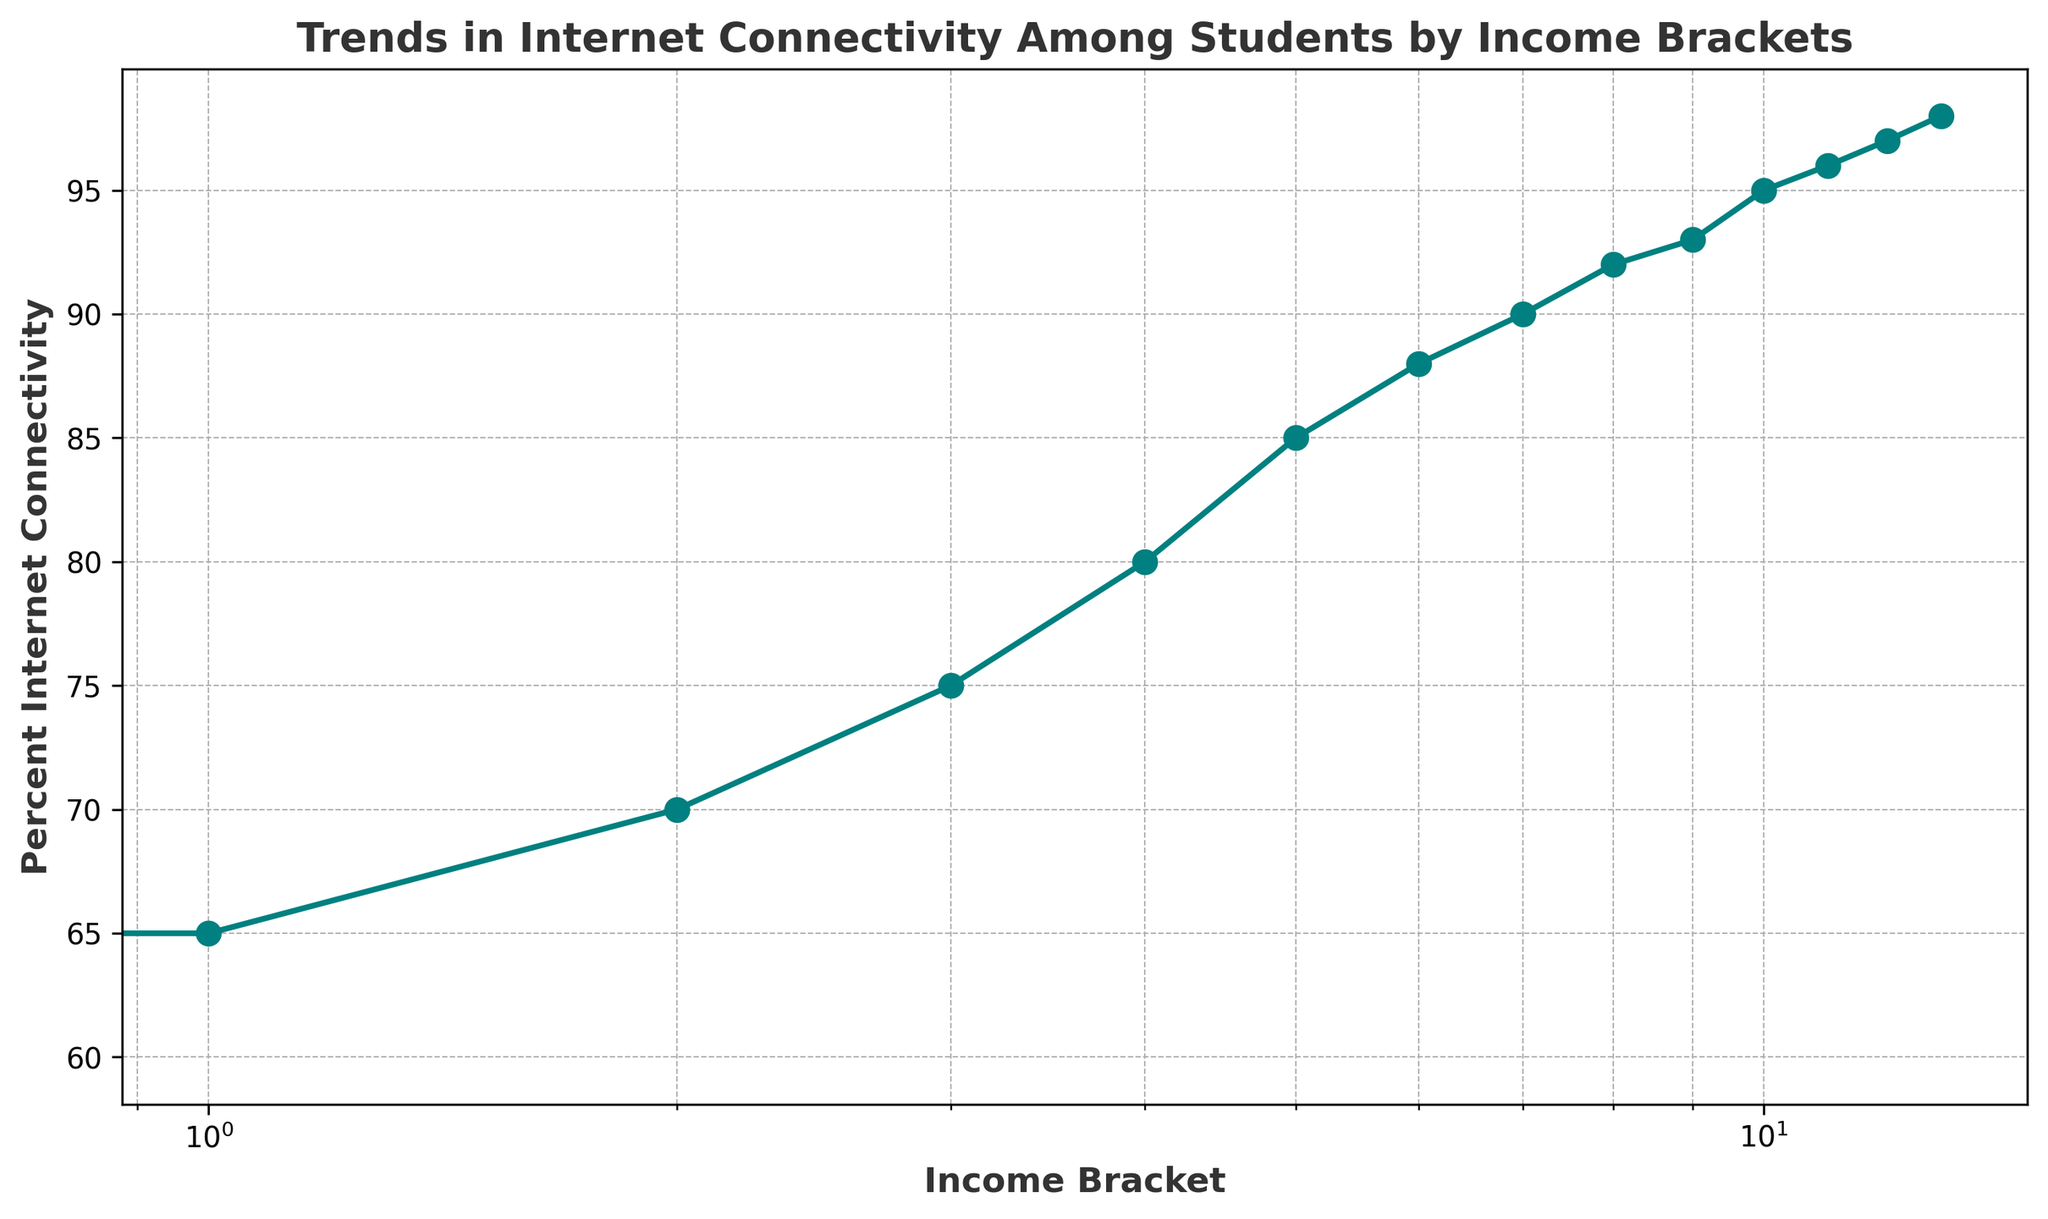What is the percentage of internet connectivity for students with income less than $10k? Locate the data point corresponding to "Less_than_10k" on the income bracket axis. The y-axis value at this point indicates the percentage, which is 60%.
Answer: 60% How much higher is the internet connectivity for students with income between $20k and $30k compared to those with income less than $10k? Identify the y-axis values for "20k_to_30k" and "Less_than_10k", which are 70% and 60%, respectively. Subtract the lower percentage from the higher one: 70% - 60% = 10%.
Answer: 10% Which income bracket has the highest percentage of internet connectivity? Look at the plot and find the data point with the highest y-axis value. The highest percentage is at "More_than_200k" with 98%.
Answer: More_than_200k What is the average percentage of internet connectivity for income brackets ranging from $50k to $100k? Identify the y-axis values for the income brackets "50k_to_60k", "60k_to_70k", "70k_to_80k", "80k_to_90k", and "90k_to_100k", which are 85%, 88%, 90%, 92%, and 93% respectively. Calculate the average: (85 + 88 + 90 + 92 + 93) / 5 = 89.6%.
Answer: 89.6% Is there an income bracket where the percentage of internet connectivity is exactly 80%? Locate the data points on the plot and check the y-axis values. The connectivity percentage is exactly 80% at the "40k_to_50k" income bracket.
Answer: 40k_to_50k Between which two consecutive income brackets does the largest increase in internet connectivity percentage occur? Check the differences between consecutive y-axis values: 
  - 10k_to_20k - Less_than_10k: 65% - 60% = 5%
  - 20k_to_30k - 10k_to_20k: 70% - 65% = 5%
  - 30k_to_40k - 20k_to_30k: 75% - 70% = 5%
  - 40k_to_50k - 30k_to_40k: 80% - 75% = 5%
  - 50k_to_60k - 40k_to_50k: 85% - 80% = 5%
  - 60k_to_70k - 50k_to_60k: 88% - 85% = 3%
  - 70k_to_80k - 60k_to_70k: 90% - 88% = 2%
  - 80k_to_90k - 70k_to_80k: 92% - 90% = 2%
  - 90k_to_100k - 80k_to_90k: 93% - 92% = 1%
  - 100k_to_125k - 90k_to_100k: 95% - 93% = 2%
  - 125k_to_150k - 100k_to_125k: 96% - 95% = 1%
  - 150k_to_200k - 125k_to_150k: 97% - 96% = 1%
  - More_than_200k - 150k_to_200k: 98% - 97% = 1%
The largest increase of 5% occurs between multiple consecutive income brackets: "Less_than_10k" to "10k_to_20k", "10k_to_20k" to "20k_to_30k", "20k_to_30k" to "30k_to_40k", "30k_to_40k" to "40k_to_50k", and "40k_to_50k" to "50k_to_60k".
Answer: Less_than_10k to 10k_to_20k, 10k_to_20k to 20k_to_30k, 20k_to_30k to 30k_to_40k, 30k_to_40k to 40k_to_50k, 40k_to_50k to 50k_to_60k 